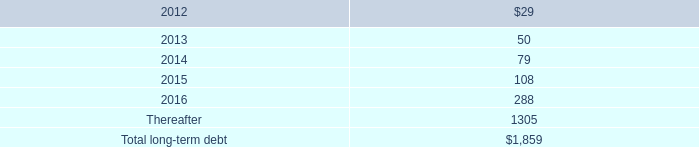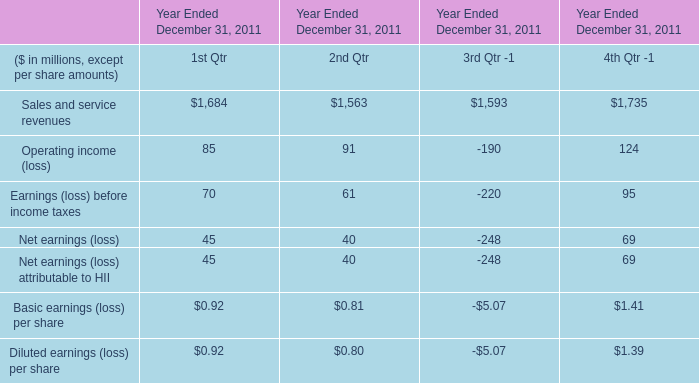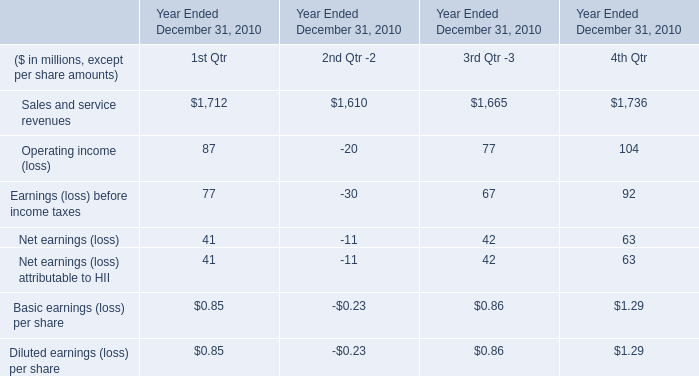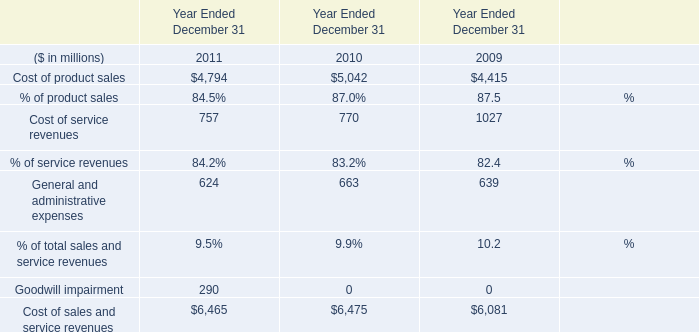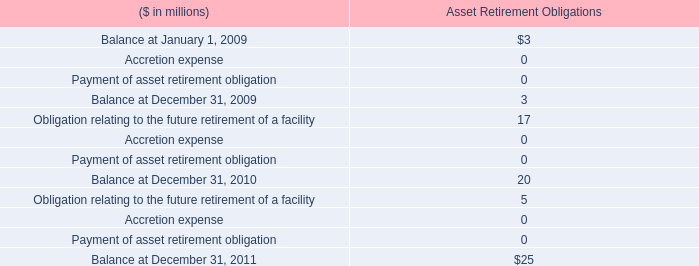how is the cash flow statement from financing activities affected by the change in the balance of the long-term debt from 2010 to 2011? 
Computations: (1864 - 128)
Answer: 1736.0. 